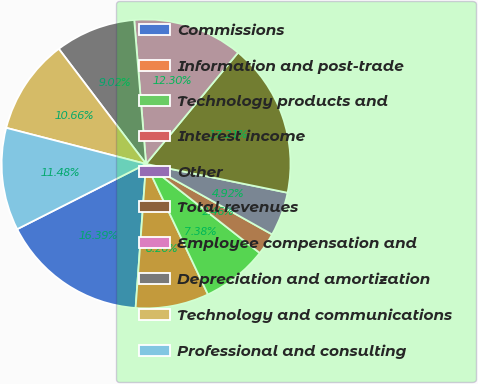Convert chart. <chart><loc_0><loc_0><loc_500><loc_500><pie_chart><fcel>Commissions<fcel>Information and post-trade<fcel>Technology products and<fcel>Interest income<fcel>Other<fcel>Total revenues<fcel>Employee compensation and<fcel>Depreciation and amortization<fcel>Technology and communications<fcel>Professional and consulting<nl><fcel>16.39%<fcel>8.2%<fcel>7.38%<fcel>2.46%<fcel>4.92%<fcel>17.21%<fcel>12.3%<fcel>9.02%<fcel>10.66%<fcel>11.48%<nl></chart> 